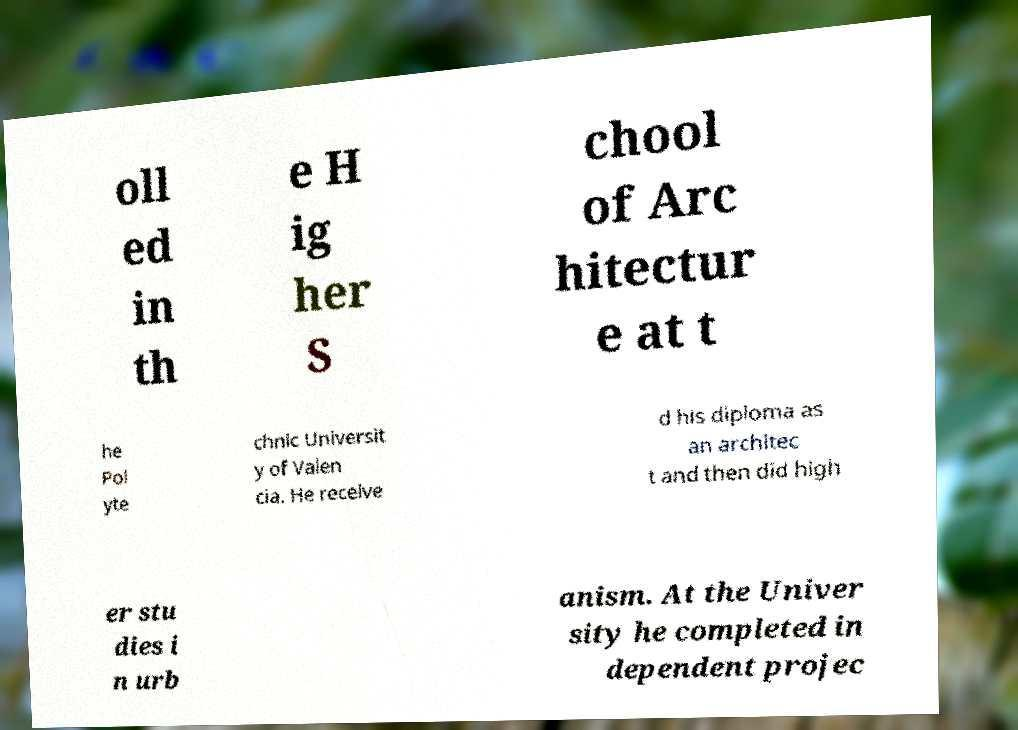Could you extract and type out the text from this image? oll ed in th e H ig her S chool of Arc hitectur e at t he Pol yte chnic Universit y of Valen cia. He receive d his diploma as an architec t and then did high er stu dies i n urb anism. At the Univer sity he completed in dependent projec 